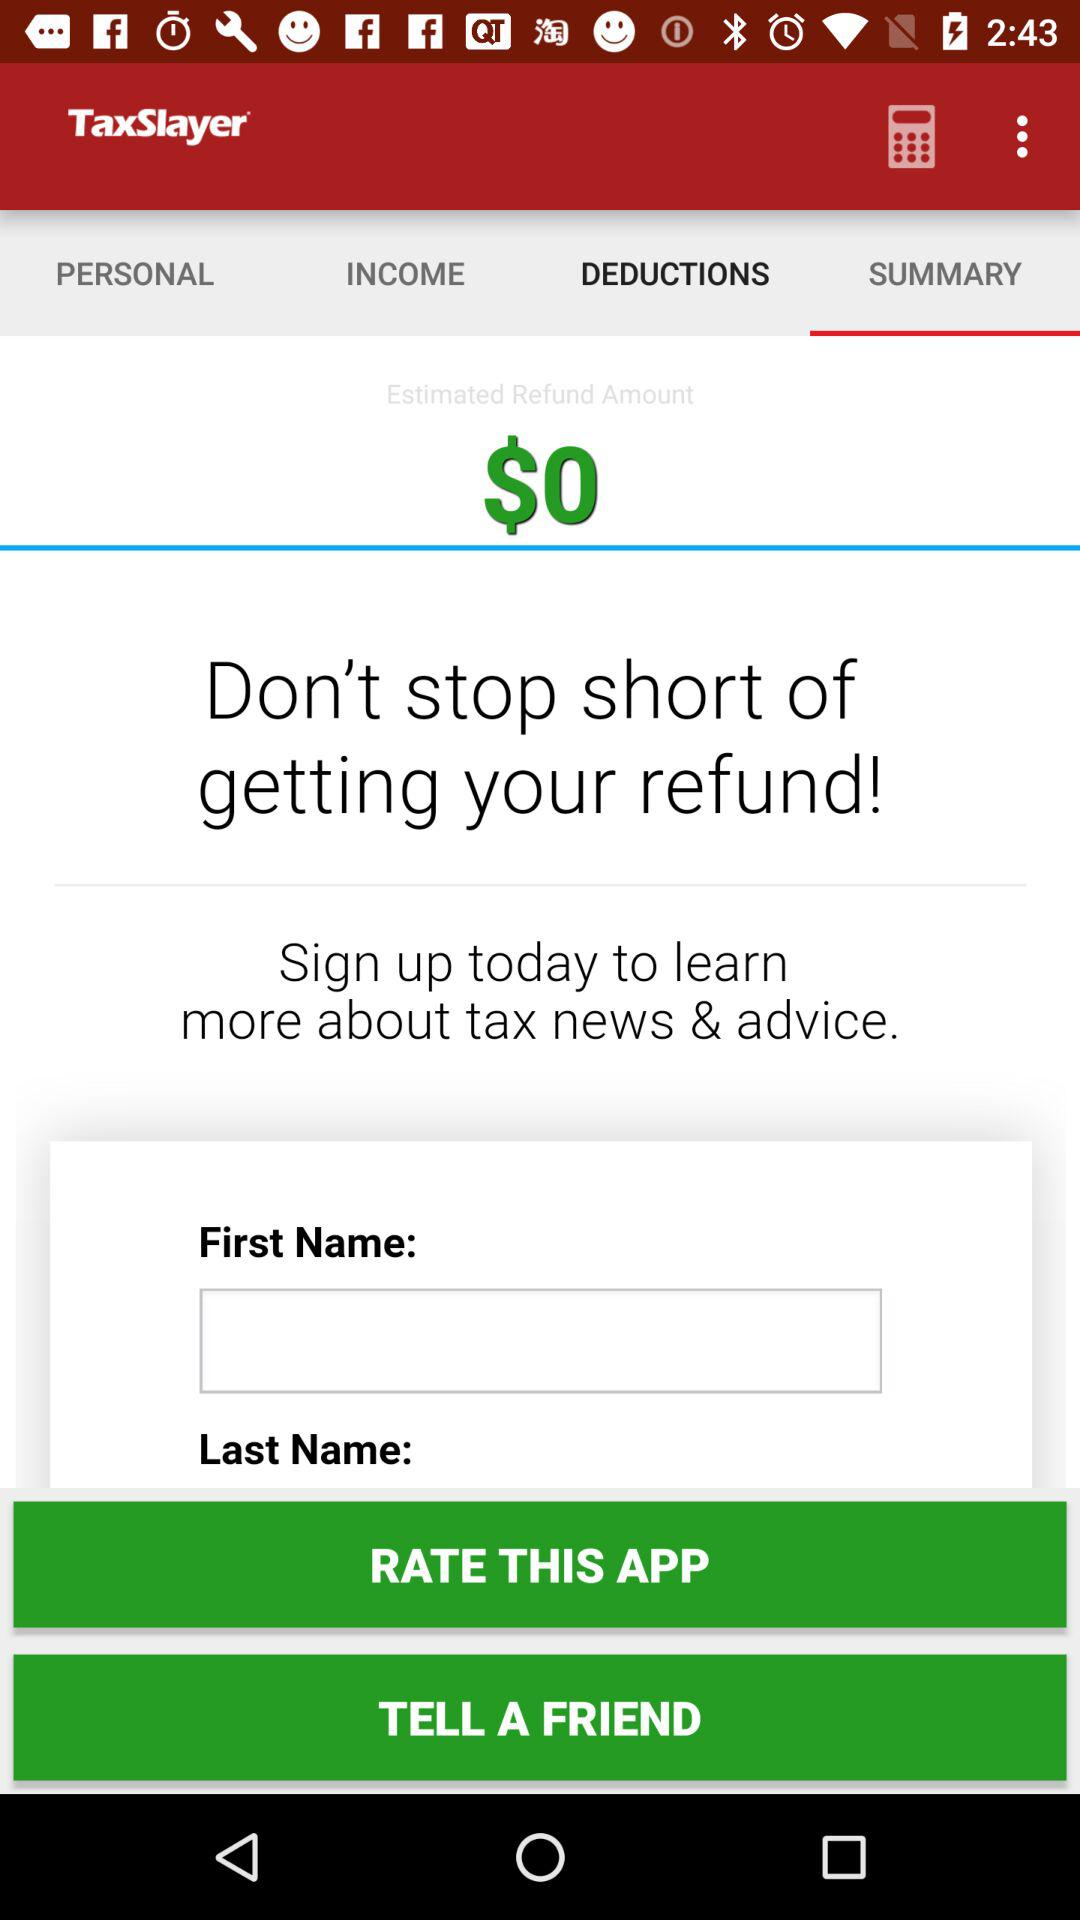What is the currency of the "Estimated refund amount"? The currency is the dollar. 